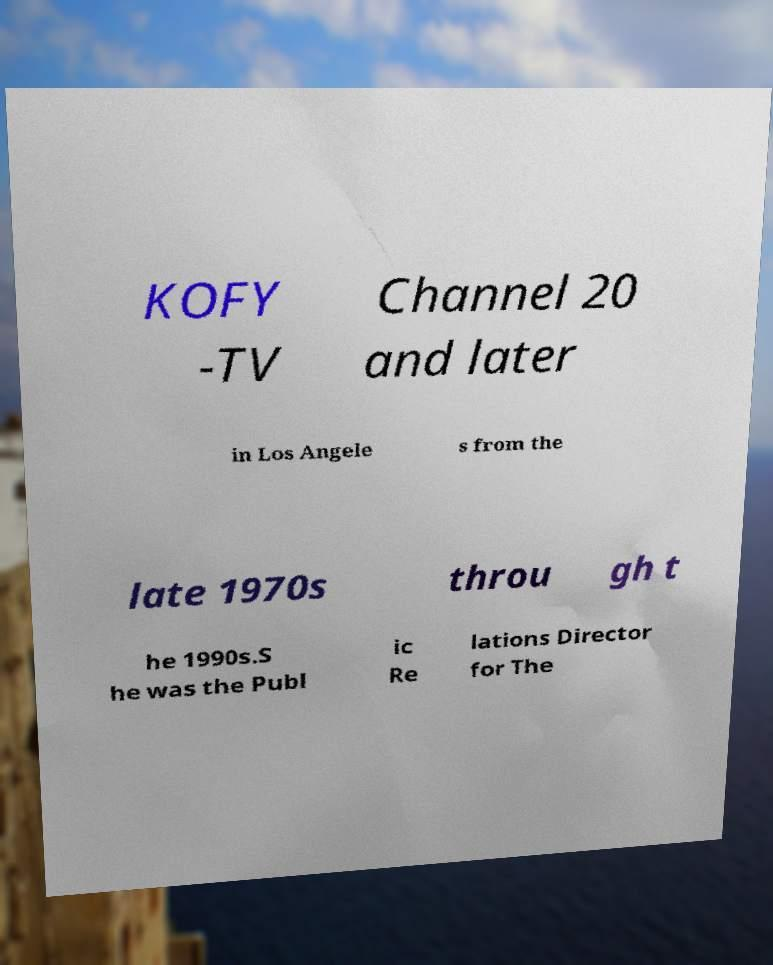I need the written content from this picture converted into text. Can you do that? KOFY -TV Channel 20 and later in Los Angele s from the late 1970s throu gh t he 1990s.S he was the Publ ic Re lations Director for The 